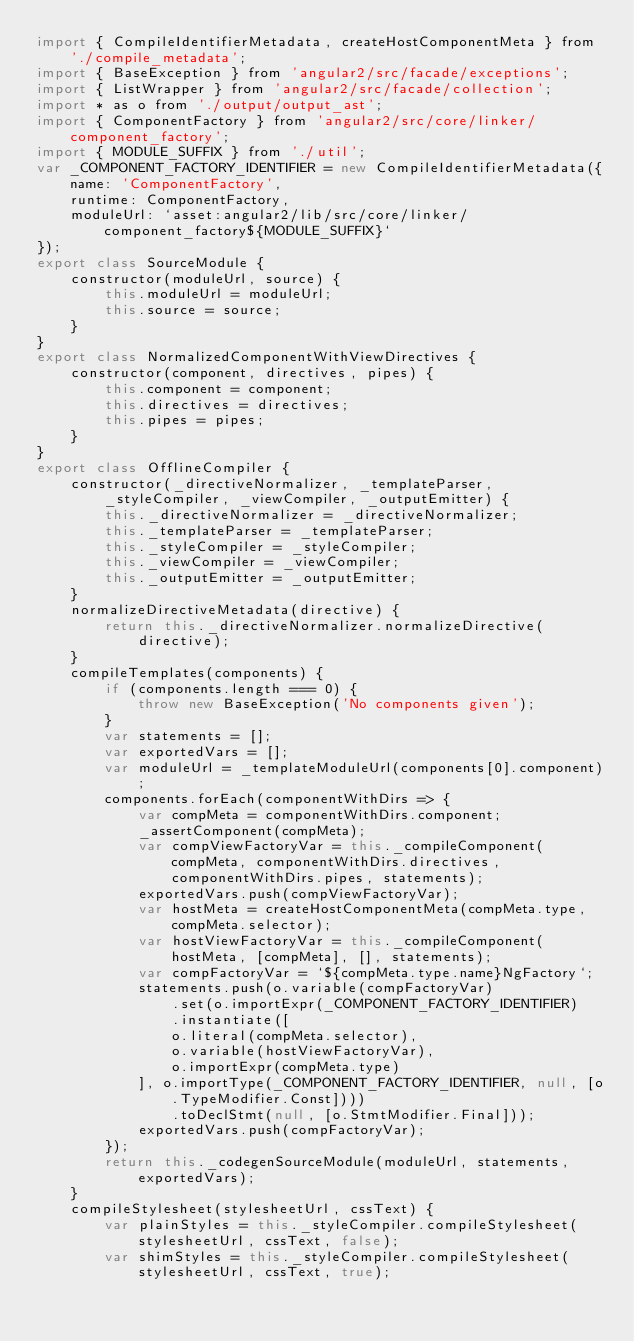<code> <loc_0><loc_0><loc_500><loc_500><_JavaScript_>import { CompileIdentifierMetadata, createHostComponentMeta } from './compile_metadata';
import { BaseException } from 'angular2/src/facade/exceptions';
import { ListWrapper } from 'angular2/src/facade/collection';
import * as o from './output/output_ast';
import { ComponentFactory } from 'angular2/src/core/linker/component_factory';
import { MODULE_SUFFIX } from './util';
var _COMPONENT_FACTORY_IDENTIFIER = new CompileIdentifierMetadata({
    name: 'ComponentFactory',
    runtime: ComponentFactory,
    moduleUrl: `asset:angular2/lib/src/core/linker/component_factory${MODULE_SUFFIX}`
});
export class SourceModule {
    constructor(moduleUrl, source) {
        this.moduleUrl = moduleUrl;
        this.source = source;
    }
}
export class NormalizedComponentWithViewDirectives {
    constructor(component, directives, pipes) {
        this.component = component;
        this.directives = directives;
        this.pipes = pipes;
    }
}
export class OfflineCompiler {
    constructor(_directiveNormalizer, _templateParser, _styleCompiler, _viewCompiler, _outputEmitter) {
        this._directiveNormalizer = _directiveNormalizer;
        this._templateParser = _templateParser;
        this._styleCompiler = _styleCompiler;
        this._viewCompiler = _viewCompiler;
        this._outputEmitter = _outputEmitter;
    }
    normalizeDirectiveMetadata(directive) {
        return this._directiveNormalizer.normalizeDirective(directive);
    }
    compileTemplates(components) {
        if (components.length === 0) {
            throw new BaseException('No components given');
        }
        var statements = [];
        var exportedVars = [];
        var moduleUrl = _templateModuleUrl(components[0].component);
        components.forEach(componentWithDirs => {
            var compMeta = componentWithDirs.component;
            _assertComponent(compMeta);
            var compViewFactoryVar = this._compileComponent(compMeta, componentWithDirs.directives, componentWithDirs.pipes, statements);
            exportedVars.push(compViewFactoryVar);
            var hostMeta = createHostComponentMeta(compMeta.type, compMeta.selector);
            var hostViewFactoryVar = this._compileComponent(hostMeta, [compMeta], [], statements);
            var compFactoryVar = `${compMeta.type.name}NgFactory`;
            statements.push(o.variable(compFactoryVar)
                .set(o.importExpr(_COMPONENT_FACTORY_IDENTIFIER)
                .instantiate([
                o.literal(compMeta.selector),
                o.variable(hostViewFactoryVar),
                o.importExpr(compMeta.type)
            ], o.importType(_COMPONENT_FACTORY_IDENTIFIER, null, [o.TypeModifier.Const])))
                .toDeclStmt(null, [o.StmtModifier.Final]));
            exportedVars.push(compFactoryVar);
        });
        return this._codegenSourceModule(moduleUrl, statements, exportedVars);
    }
    compileStylesheet(stylesheetUrl, cssText) {
        var plainStyles = this._styleCompiler.compileStylesheet(stylesheetUrl, cssText, false);
        var shimStyles = this._styleCompiler.compileStylesheet(stylesheetUrl, cssText, true);</code> 